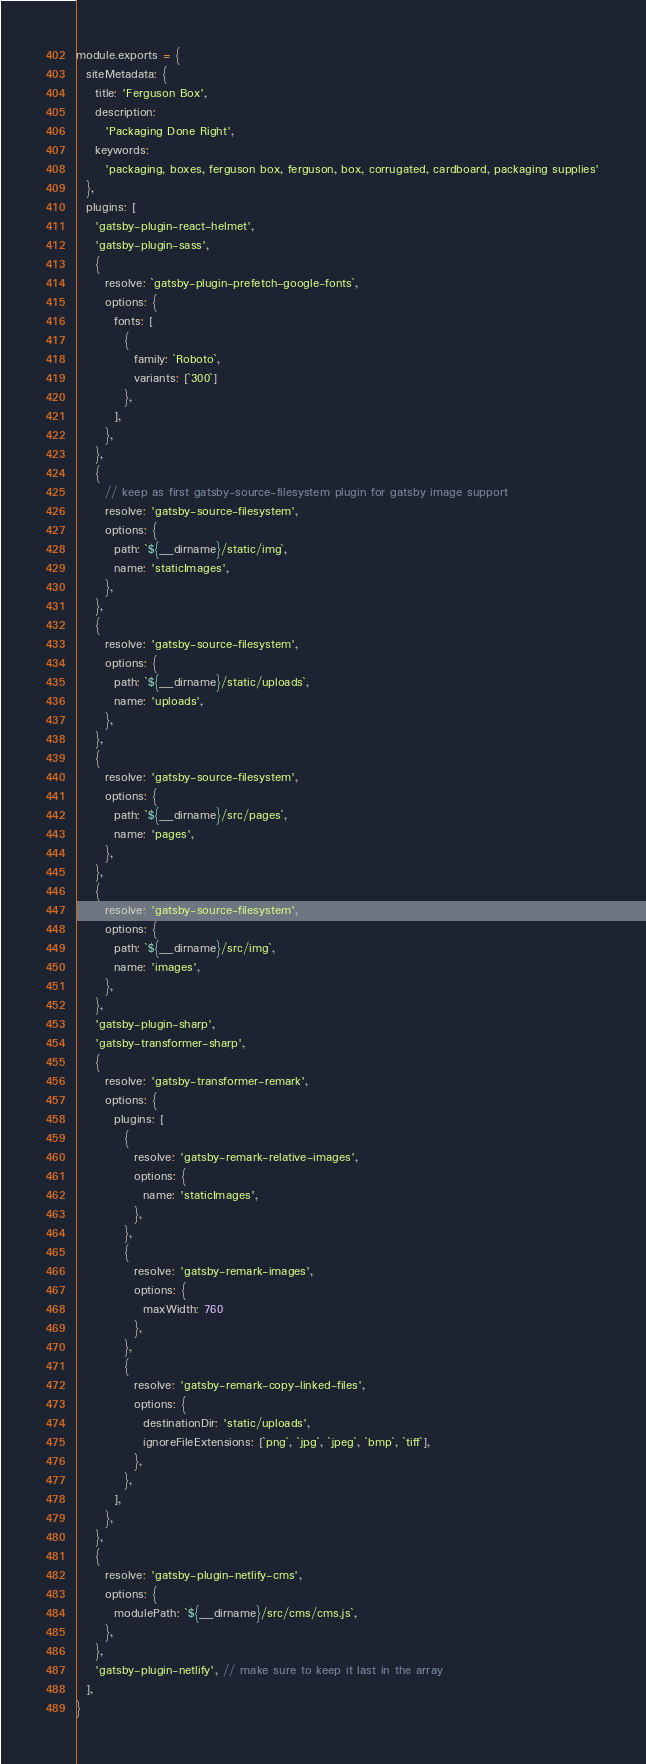Convert code to text. <code><loc_0><loc_0><loc_500><loc_500><_JavaScript_>module.exports = {
  siteMetadata: {
    title: 'Ferguson Box',
    description:
      'Packaging Done Right',
    keywords:
      'packaging, boxes, ferguson box, ferguson, box, corrugated, cardboard, packaging supplies'
  },
  plugins: [
    'gatsby-plugin-react-helmet',
    'gatsby-plugin-sass',
    {
      resolve: `gatsby-plugin-prefetch-google-fonts`,
      options: {
        fonts: [
          {
            family: `Roboto`,
            variants: [`300`]
          },
        ],
      },
    },
    {
      // keep as first gatsby-source-filesystem plugin for gatsby image support
      resolve: 'gatsby-source-filesystem',
      options: {
        path: `${__dirname}/static/img`,
        name: 'staticImages',
      },
    },
    {
      resolve: 'gatsby-source-filesystem',
      options: {
        path: `${__dirname}/static/uploads`,
        name: 'uploads',
      },
    },
    {
      resolve: 'gatsby-source-filesystem',
      options: {
        path: `${__dirname}/src/pages`,
        name: 'pages',
      },
    },
    {
      resolve: 'gatsby-source-filesystem',
      options: {
        path: `${__dirname}/src/img`,
        name: 'images',
      },
    },
    'gatsby-plugin-sharp',
    'gatsby-transformer-sharp',
    {
      resolve: 'gatsby-transformer-remark',
      options: {
        plugins: [
          {
            resolve: 'gatsby-remark-relative-images',
            options: {
              name: 'staticImages',
            },
          },
          {
            resolve: 'gatsby-remark-images',
            options: {
              maxWidth: 760
            },
          },
          {
            resolve: 'gatsby-remark-copy-linked-files',
            options: {
              destinationDir: 'static/uploads',
              ignoreFileExtensions: [`png`, `jpg`, `jpeg`, `bmp`, `tiff`],
            },
          },
        ],
      },
    },
    {
      resolve: 'gatsby-plugin-netlify-cms',
      options: {
        modulePath: `${__dirname}/src/cms/cms.js`,
      },
    },
    'gatsby-plugin-netlify', // make sure to keep it last in the array
  ],
}
</code> 